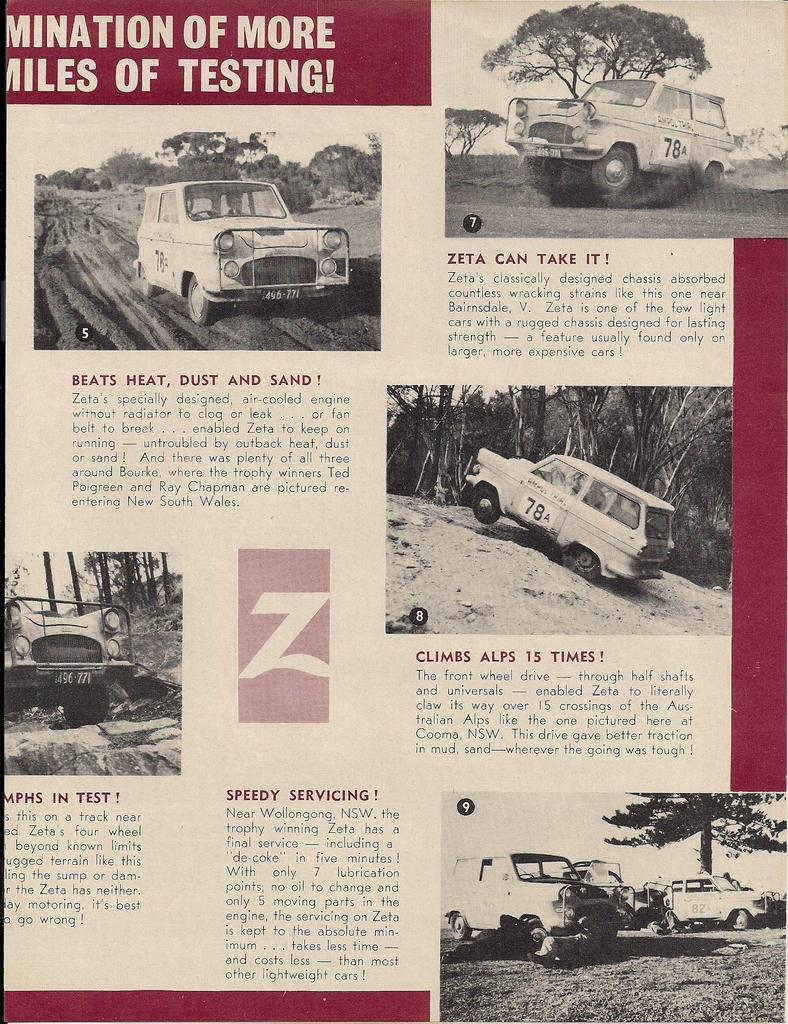What is the main object in the image? There is a magazine in the image. What type of content is featured in the magazine? The magazine contains images of a car and some information. Is there an umbrella being used to protect the car from the fire in the image? There is no umbrella or fire present in the image; it only features a magazine with images of a car. 